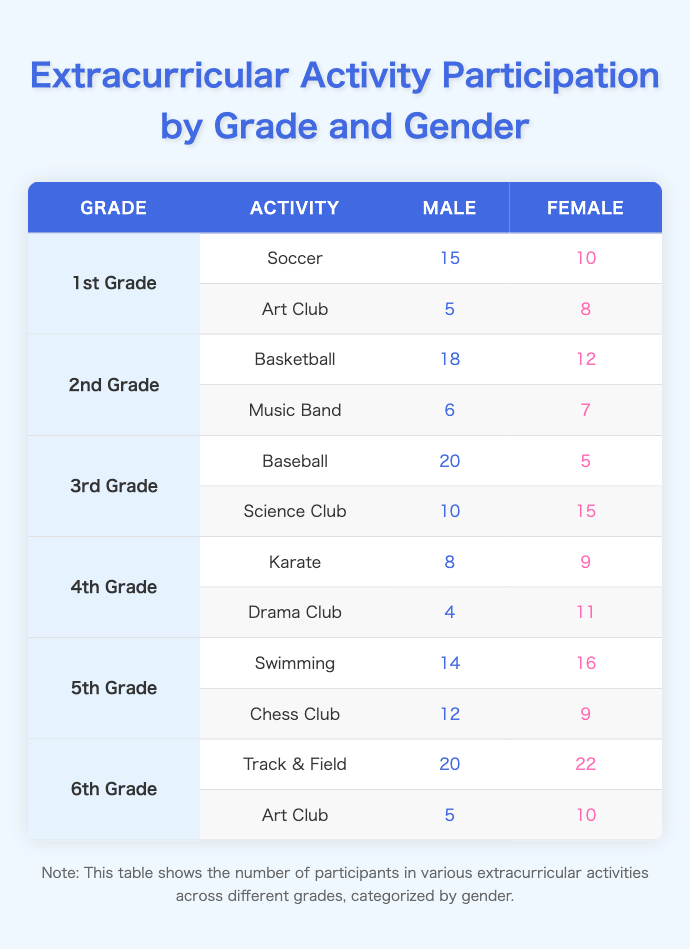What is the total number of male participants in the 2nd Grade activities? To find the total number of male participants in the 2nd Grade, I need to look at the two activities listed for that grade: Basketball and Music Band. For Basketball, there are 18 male participants, and for Music Band, there are 6. Therefore, I add these numbers together: 18 + 6 = 24.
Answer: 24 Which activity had the highest female participation and how many participants were there? I need to compare the number of female participants across all activities. By examining each row, the highest value is from Track & Field in the 6th Grade with 22 female participants.
Answer: 22 Is it true that there are more boys than girls in the 3rd Grade activities? To assess this, I need to tally the number of male and female participants in the 3rd Grade. For Baseball, there are 20 boys and 5 girls; for Science Club, there are 10 boys and 15 girls. Summing these: 20 + 10 = 30 boys and 5 + 15 = 20 girls. Since 30 is greater than 20, the statement is true.
Answer: Yes What is the difference in participants between male and female in the Karate club for 4th Grade? I need to look specifically at the Karate club for 4th Grade. There are 8 male participants and 9 female participants. The difference is calculated by subtracting the smaller number from the larger one: 9 - 8 = 1.
Answer: 1 What is the average number of participants for male students across all activities? First, I sum the male participants in each activity: 15 (Soccer) + 5 (Art Club, 1st Grade) + 18 (Basketball) + 6 (Music Band, 2nd Grade) + 20 (Baseball) + 10 (Science Club, 3rd Grade) + 8 (Karate) + 4 (Drama Club, 4th Grade) + 14 (Swimming) + 12 (Chess Club, 5th Grade) + 20 (Track & Field) + 5 (Art Club, 6th Grade) =  128. There are 12 activities in total, so I divide: 128 / 12 = 10.67.
Answer: 10.67 